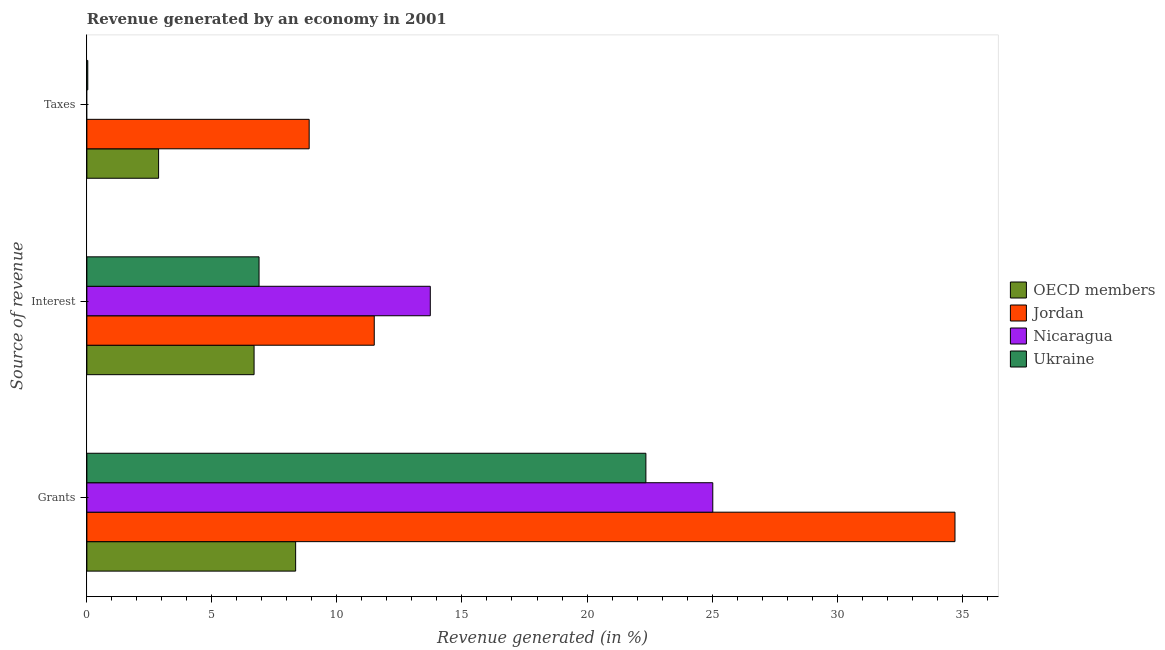How many different coloured bars are there?
Your answer should be very brief. 4. How many groups of bars are there?
Offer a very short reply. 3. Are the number of bars per tick equal to the number of legend labels?
Offer a very short reply. No. Are the number of bars on each tick of the Y-axis equal?
Keep it short and to the point. No. How many bars are there on the 2nd tick from the bottom?
Keep it short and to the point. 4. What is the label of the 2nd group of bars from the top?
Make the answer very short. Interest. What is the percentage of revenue generated by taxes in Nicaragua?
Your answer should be very brief. 0. Across all countries, what is the maximum percentage of revenue generated by interest?
Give a very brief answer. 13.73. Across all countries, what is the minimum percentage of revenue generated by interest?
Your response must be concise. 6.69. In which country was the percentage of revenue generated by taxes maximum?
Keep it short and to the point. Jordan. What is the total percentage of revenue generated by taxes in the graph?
Your answer should be compact. 11.79. What is the difference between the percentage of revenue generated by taxes in Jordan and that in Ukraine?
Keep it short and to the point. 8.85. What is the difference between the percentage of revenue generated by grants in Ukraine and the percentage of revenue generated by taxes in Nicaragua?
Your answer should be very brief. 22.35. What is the average percentage of revenue generated by taxes per country?
Your answer should be very brief. 2.95. What is the difference between the percentage of revenue generated by grants and percentage of revenue generated by taxes in Jordan?
Ensure brevity in your answer.  25.83. In how many countries, is the percentage of revenue generated by grants greater than 29 %?
Your response must be concise. 1. What is the ratio of the percentage of revenue generated by taxes in OECD members to that in Jordan?
Make the answer very short. 0.32. Is the percentage of revenue generated by taxes in OECD members less than that in Jordan?
Your response must be concise. Yes. What is the difference between the highest and the second highest percentage of revenue generated by taxes?
Make the answer very short. 6.02. What is the difference between the highest and the lowest percentage of revenue generated by interest?
Your answer should be very brief. 7.05. Is the sum of the percentage of revenue generated by interest in OECD members and Jordan greater than the maximum percentage of revenue generated by grants across all countries?
Your answer should be very brief. No. Is it the case that in every country, the sum of the percentage of revenue generated by grants and percentage of revenue generated by interest is greater than the percentage of revenue generated by taxes?
Your response must be concise. Yes. How many bars are there?
Give a very brief answer. 11. How many countries are there in the graph?
Give a very brief answer. 4. What is the difference between two consecutive major ticks on the X-axis?
Your answer should be very brief. 5. Are the values on the major ticks of X-axis written in scientific E-notation?
Give a very brief answer. No. Where does the legend appear in the graph?
Give a very brief answer. Center right. What is the title of the graph?
Your response must be concise. Revenue generated by an economy in 2001. Does "West Bank and Gaza" appear as one of the legend labels in the graph?
Give a very brief answer. No. What is the label or title of the X-axis?
Give a very brief answer. Revenue generated (in %). What is the label or title of the Y-axis?
Your answer should be compact. Source of revenue. What is the Revenue generated (in %) of OECD members in Grants?
Your answer should be compact. 8.35. What is the Revenue generated (in %) of Jordan in Grants?
Keep it short and to the point. 34.71. What is the Revenue generated (in %) of Nicaragua in Grants?
Provide a short and direct response. 25.03. What is the Revenue generated (in %) of Ukraine in Grants?
Your response must be concise. 22.35. What is the Revenue generated (in %) of OECD members in Interest?
Your answer should be compact. 6.69. What is the Revenue generated (in %) in Jordan in Interest?
Your answer should be very brief. 11.49. What is the Revenue generated (in %) in Nicaragua in Interest?
Make the answer very short. 13.73. What is the Revenue generated (in %) of Ukraine in Interest?
Provide a short and direct response. 6.88. What is the Revenue generated (in %) of OECD members in Taxes?
Provide a succinct answer. 2.87. What is the Revenue generated (in %) of Jordan in Taxes?
Make the answer very short. 8.89. What is the Revenue generated (in %) of Ukraine in Taxes?
Keep it short and to the point. 0.04. Across all Source of revenue, what is the maximum Revenue generated (in %) of OECD members?
Provide a short and direct response. 8.35. Across all Source of revenue, what is the maximum Revenue generated (in %) in Jordan?
Your answer should be very brief. 34.71. Across all Source of revenue, what is the maximum Revenue generated (in %) of Nicaragua?
Offer a terse response. 25.03. Across all Source of revenue, what is the maximum Revenue generated (in %) of Ukraine?
Offer a very short reply. 22.35. Across all Source of revenue, what is the minimum Revenue generated (in %) of OECD members?
Provide a succinct answer. 2.87. Across all Source of revenue, what is the minimum Revenue generated (in %) of Jordan?
Offer a very short reply. 8.89. Across all Source of revenue, what is the minimum Revenue generated (in %) of Nicaragua?
Offer a very short reply. 0. Across all Source of revenue, what is the minimum Revenue generated (in %) in Ukraine?
Provide a short and direct response. 0.04. What is the total Revenue generated (in %) of OECD members in the graph?
Provide a succinct answer. 17.9. What is the total Revenue generated (in %) in Jordan in the graph?
Offer a terse response. 55.1. What is the total Revenue generated (in %) of Nicaragua in the graph?
Offer a terse response. 38.76. What is the total Revenue generated (in %) in Ukraine in the graph?
Provide a succinct answer. 29.28. What is the difference between the Revenue generated (in %) of OECD members in Grants and that in Interest?
Make the answer very short. 1.66. What is the difference between the Revenue generated (in %) of Jordan in Grants and that in Interest?
Provide a succinct answer. 23.22. What is the difference between the Revenue generated (in %) of Nicaragua in Grants and that in Interest?
Your answer should be compact. 11.3. What is the difference between the Revenue generated (in %) in Ukraine in Grants and that in Interest?
Your response must be concise. 15.47. What is the difference between the Revenue generated (in %) in OECD members in Grants and that in Taxes?
Give a very brief answer. 5.48. What is the difference between the Revenue generated (in %) in Jordan in Grants and that in Taxes?
Keep it short and to the point. 25.83. What is the difference between the Revenue generated (in %) of Ukraine in Grants and that in Taxes?
Offer a terse response. 22.32. What is the difference between the Revenue generated (in %) in OECD members in Interest and that in Taxes?
Your answer should be very brief. 3.82. What is the difference between the Revenue generated (in %) in Jordan in Interest and that in Taxes?
Your response must be concise. 2.6. What is the difference between the Revenue generated (in %) of Ukraine in Interest and that in Taxes?
Provide a succinct answer. 6.85. What is the difference between the Revenue generated (in %) in OECD members in Grants and the Revenue generated (in %) in Jordan in Interest?
Offer a very short reply. -3.14. What is the difference between the Revenue generated (in %) in OECD members in Grants and the Revenue generated (in %) in Nicaragua in Interest?
Offer a terse response. -5.38. What is the difference between the Revenue generated (in %) of OECD members in Grants and the Revenue generated (in %) of Ukraine in Interest?
Provide a short and direct response. 1.46. What is the difference between the Revenue generated (in %) in Jordan in Grants and the Revenue generated (in %) in Nicaragua in Interest?
Your response must be concise. 20.98. What is the difference between the Revenue generated (in %) of Jordan in Grants and the Revenue generated (in %) of Ukraine in Interest?
Your answer should be compact. 27.83. What is the difference between the Revenue generated (in %) of Nicaragua in Grants and the Revenue generated (in %) of Ukraine in Interest?
Your answer should be compact. 18.14. What is the difference between the Revenue generated (in %) of OECD members in Grants and the Revenue generated (in %) of Jordan in Taxes?
Provide a succinct answer. -0.54. What is the difference between the Revenue generated (in %) of OECD members in Grants and the Revenue generated (in %) of Ukraine in Taxes?
Your answer should be very brief. 8.31. What is the difference between the Revenue generated (in %) in Jordan in Grants and the Revenue generated (in %) in Ukraine in Taxes?
Offer a terse response. 34.68. What is the difference between the Revenue generated (in %) in Nicaragua in Grants and the Revenue generated (in %) in Ukraine in Taxes?
Keep it short and to the point. 24.99. What is the difference between the Revenue generated (in %) of OECD members in Interest and the Revenue generated (in %) of Jordan in Taxes?
Offer a terse response. -2.2. What is the difference between the Revenue generated (in %) of OECD members in Interest and the Revenue generated (in %) of Ukraine in Taxes?
Your response must be concise. 6.65. What is the difference between the Revenue generated (in %) in Jordan in Interest and the Revenue generated (in %) in Ukraine in Taxes?
Offer a terse response. 11.46. What is the difference between the Revenue generated (in %) of Nicaragua in Interest and the Revenue generated (in %) of Ukraine in Taxes?
Offer a very short reply. 13.7. What is the average Revenue generated (in %) in OECD members per Source of revenue?
Your response must be concise. 5.97. What is the average Revenue generated (in %) of Jordan per Source of revenue?
Make the answer very short. 18.37. What is the average Revenue generated (in %) of Nicaragua per Source of revenue?
Give a very brief answer. 12.92. What is the average Revenue generated (in %) of Ukraine per Source of revenue?
Keep it short and to the point. 9.76. What is the difference between the Revenue generated (in %) in OECD members and Revenue generated (in %) in Jordan in Grants?
Your response must be concise. -26.37. What is the difference between the Revenue generated (in %) in OECD members and Revenue generated (in %) in Nicaragua in Grants?
Offer a very short reply. -16.68. What is the difference between the Revenue generated (in %) in OECD members and Revenue generated (in %) in Ukraine in Grants?
Make the answer very short. -14.01. What is the difference between the Revenue generated (in %) in Jordan and Revenue generated (in %) in Nicaragua in Grants?
Your answer should be compact. 9.69. What is the difference between the Revenue generated (in %) of Jordan and Revenue generated (in %) of Ukraine in Grants?
Provide a succinct answer. 12.36. What is the difference between the Revenue generated (in %) in Nicaragua and Revenue generated (in %) in Ukraine in Grants?
Your answer should be very brief. 2.67. What is the difference between the Revenue generated (in %) in OECD members and Revenue generated (in %) in Jordan in Interest?
Your response must be concise. -4.81. What is the difference between the Revenue generated (in %) in OECD members and Revenue generated (in %) in Nicaragua in Interest?
Offer a terse response. -7.05. What is the difference between the Revenue generated (in %) of OECD members and Revenue generated (in %) of Ukraine in Interest?
Your answer should be compact. -0.2. What is the difference between the Revenue generated (in %) of Jordan and Revenue generated (in %) of Nicaragua in Interest?
Your answer should be compact. -2.24. What is the difference between the Revenue generated (in %) in Jordan and Revenue generated (in %) in Ukraine in Interest?
Your answer should be very brief. 4.61. What is the difference between the Revenue generated (in %) of Nicaragua and Revenue generated (in %) of Ukraine in Interest?
Give a very brief answer. 6.85. What is the difference between the Revenue generated (in %) in OECD members and Revenue generated (in %) in Jordan in Taxes?
Ensure brevity in your answer.  -6.02. What is the difference between the Revenue generated (in %) in OECD members and Revenue generated (in %) in Ukraine in Taxes?
Offer a very short reply. 2.83. What is the difference between the Revenue generated (in %) in Jordan and Revenue generated (in %) in Ukraine in Taxes?
Keep it short and to the point. 8.85. What is the ratio of the Revenue generated (in %) of OECD members in Grants to that in Interest?
Ensure brevity in your answer.  1.25. What is the ratio of the Revenue generated (in %) of Jordan in Grants to that in Interest?
Ensure brevity in your answer.  3.02. What is the ratio of the Revenue generated (in %) in Nicaragua in Grants to that in Interest?
Keep it short and to the point. 1.82. What is the ratio of the Revenue generated (in %) of Ukraine in Grants to that in Interest?
Your answer should be compact. 3.25. What is the ratio of the Revenue generated (in %) of OECD members in Grants to that in Taxes?
Provide a succinct answer. 2.91. What is the ratio of the Revenue generated (in %) in Jordan in Grants to that in Taxes?
Provide a succinct answer. 3.91. What is the ratio of the Revenue generated (in %) in Ukraine in Grants to that in Taxes?
Offer a terse response. 615.67. What is the ratio of the Revenue generated (in %) in OECD members in Interest to that in Taxes?
Provide a succinct answer. 2.33. What is the ratio of the Revenue generated (in %) of Jordan in Interest to that in Taxes?
Give a very brief answer. 1.29. What is the ratio of the Revenue generated (in %) in Ukraine in Interest to that in Taxes?
Provide a short and direct response. 189.61. What is the difference between the highest and the second highest Revenue generated (in %) of OECD members?
Your response must be concise. 1.66. What is the difference between the highest and the second highest Revenue generated (in %) in Jordan?
Make the answer very short. 23.22. What is the difference between the highest and the second highest Revenue generated (in %) in Ukraine?
Give a very brief answer. 15.47. What is the difference between the highest and the lowest Revenue generated (in %) of OECD members?
Offer a very short reply. 5.48. What is the difference between the highest and the lowest Revenue generated (in %) of Jordan?
Give a very brief answer. 25.83. What is the difference between the highest and the lowest Revenue generated (in %) of Nicaragua?
Provide a succinct answer. 25.03. What is the difference between the highest and the lowest Revenue generated (in %) of Ukraine?
Provide a succinct answer. 22.32. 